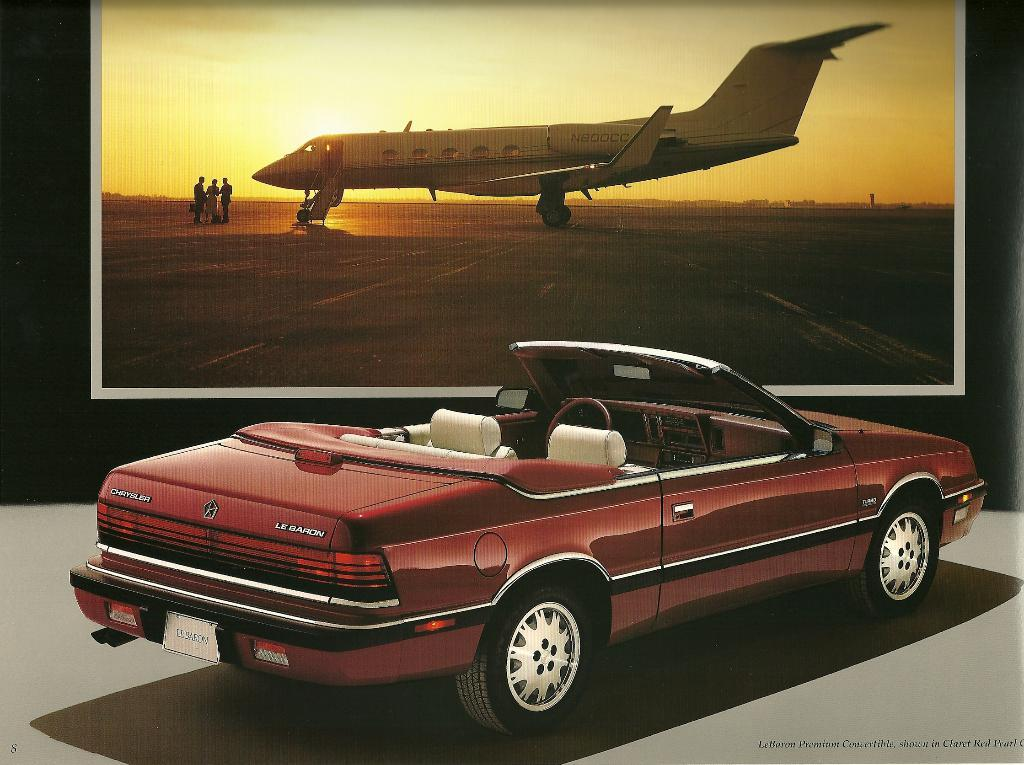<image>
Provide a brief description of the given image. A Chrysler LeBaron is parked in front of an image of a private jet. 